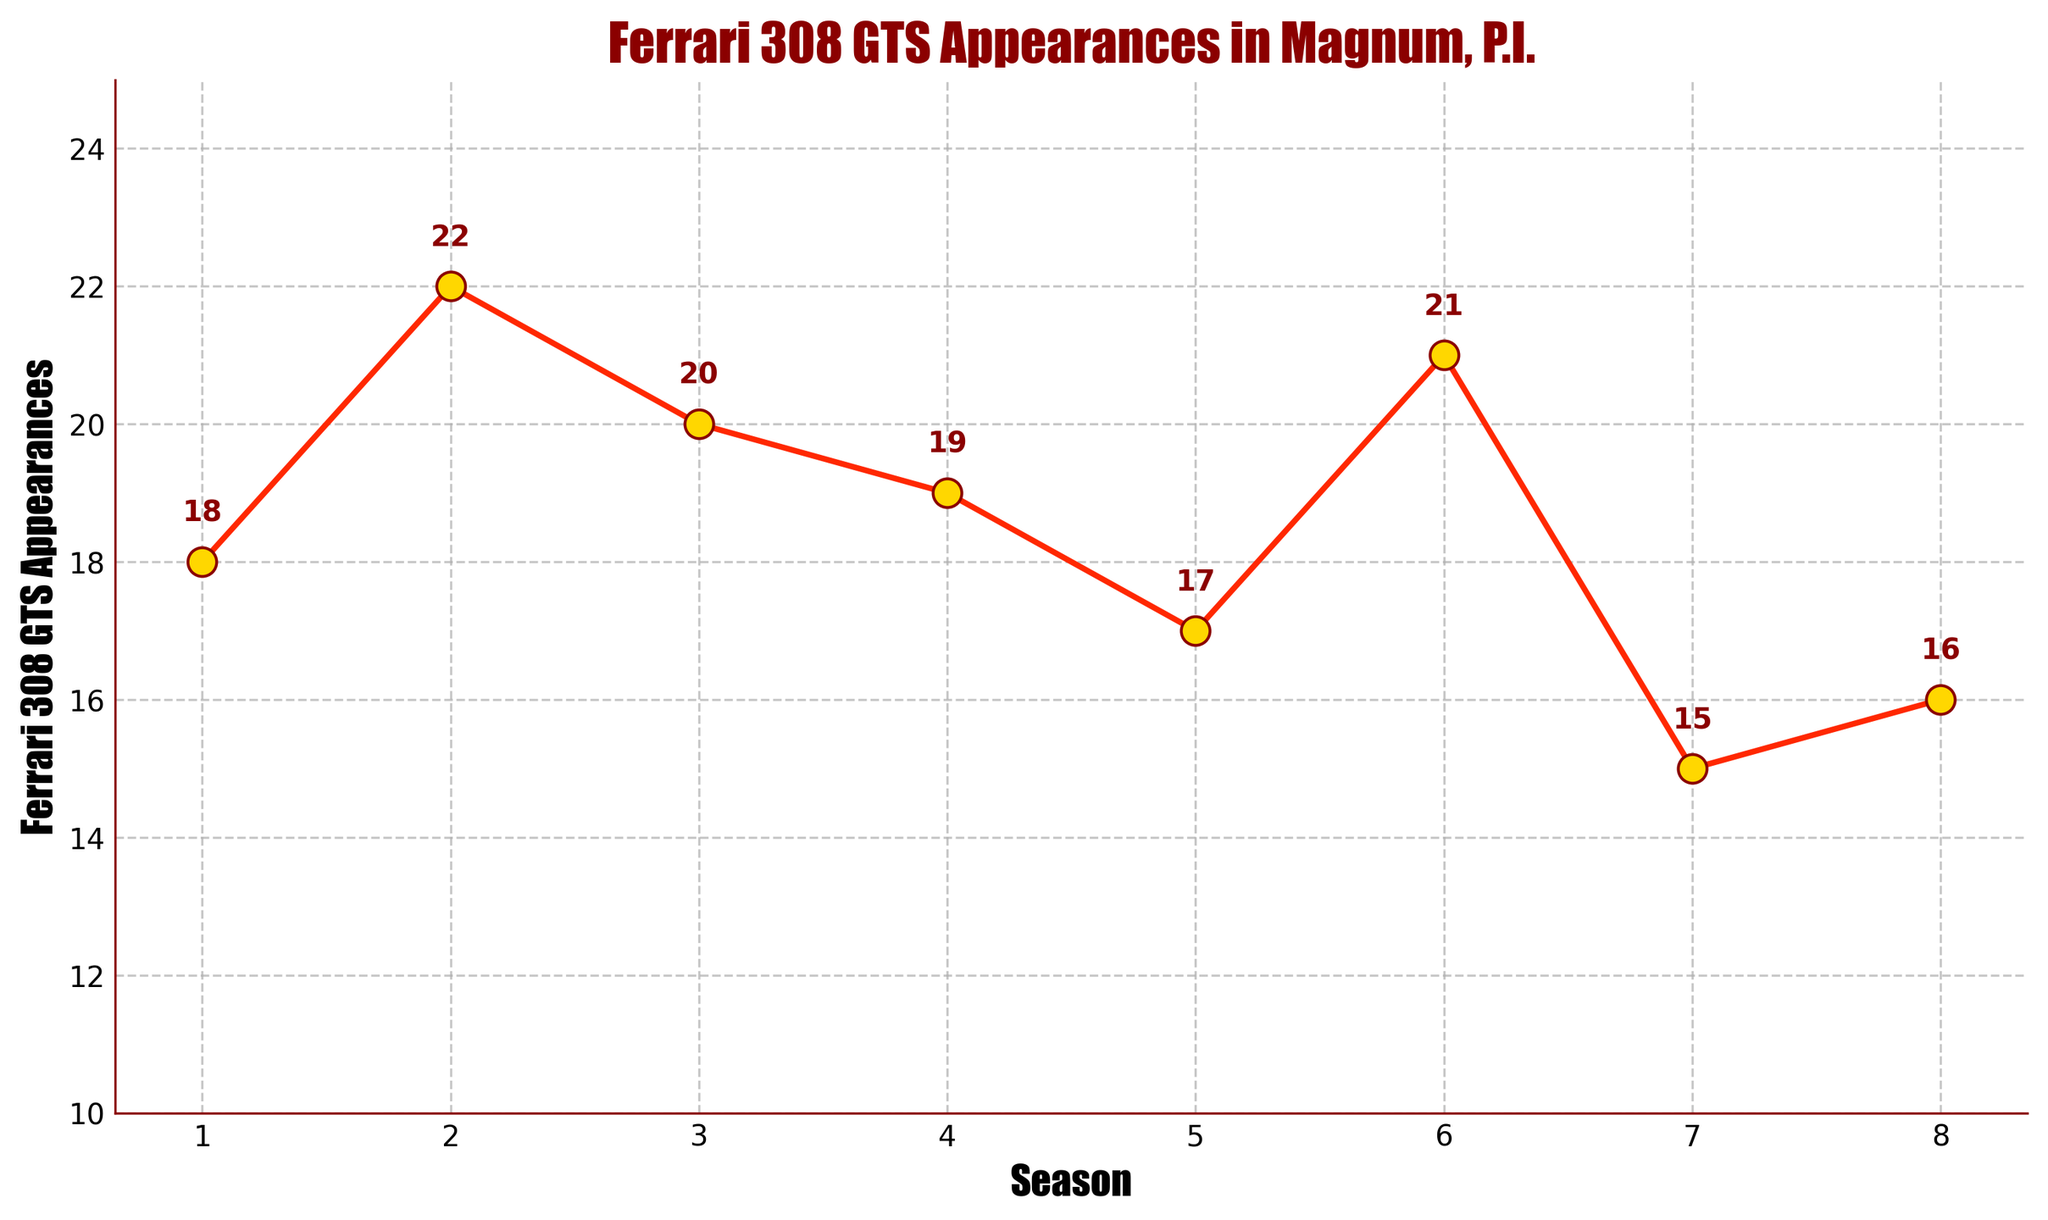What is the total number of Ferrari 308 GTS appearances in Season 1 and Season 2? Add the appearances from Season 1 (18) and Season 2 (22): 18 + 22 = 40
Answer: 40 Which season had the highest number of Ferrari 308 GTS appearances? The highest point on the chart corresponds to Season 2 with 22 appearances
Answer: Season 2 What's the difference in the number of Ferrari 308 GTS appearances between Season 6 and Season 7? Subtract the appearances in Season 7 (15) from the appearances in Season 6 (21): 21 - 15 = 6
Answer: 6 During which season did the Ferrari 308 GTS appear the least? The lowest point on the chart corresponds to Season 7 with 15 appearances
Answer: Season 7 Identify the seasons where Ferrari 308 GTS appearances are above 20. How many such seasons are there? The seasons with appearances above 20 are Season 2 (22) and Season 6 (21). There are 2 seasons.
Answer: 2 Calculate the average number of Ferrari 308 GTS appearances across all seasons. Sum all appearances and divide by the number of seasons: (18 + 22 + 20 + 19 + 17 + 21 + 15 + 16) / 8 = 148 / 8 = 18.5
Answer: 18.5 By how much does the number of Ferrari 308 GTS appearances in Season 8 differ from the number in Season 1? Subtract the appearances in Season 8 (16) from the appearances in Season 1 (18): 18 - 16 = 2
Answer: 2 Is there any season where the Ferrari 308 GTS appeared in exactly 19 episodes? Refer to the chart and find the point where the number of appearances is 19; this corresponds to Season 4
Answer: Yes, Season 4 How many seasons have fewer Ferrari 308 GTS appearances than Season 4? Seasons with fewer appearances than Season 4 (19) are Season 5 (17), Season 7 (15), and Season 8 (16). There are 3 seasons.
Answer: 3 What's the trend in Ferrari 308 GTS appearances from Season 3 to Season 5? Write down the number of appearances: Season 3 (20), Season 4 (19), Season 5 (17). The number decreases from Season 3 to Season 5
Answer: Decreasing 